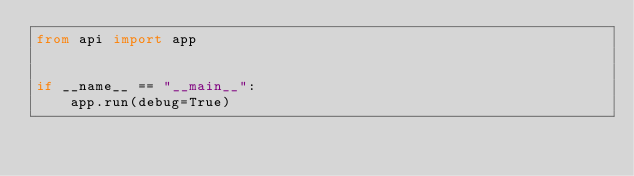<code> <loc_0><loc_0><loc_500><loc_500><_Python_>from api import app


if __name__ == "__main__":
    app.run(debug=True)

</code> 